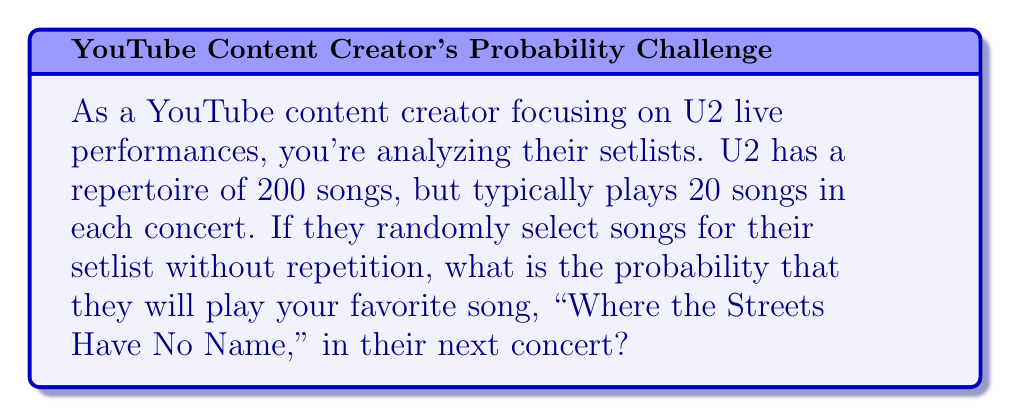Give your solution to this math problem. To solve this problem, we need to use the concept of probability in combination problems. Let's break it down step-by-step:

1) The total number of possible ways to select 20 songs from 200 songs is given by the combination formula:

   $$\binom{200}{20} = \frac{200!}{20!(200-20)!} = \frac{200!}{20!180!}$$

2) Now, we want to calculate the number of ways to select 20 songs that include "Where the Streets Have No Name". This is equivalent to selecting 19 songs from the remaining 199 songs:

   $$\binom{199}{19} = \frac{199!}{19!(199-19)!} = \frac{199!}{19!180!}$$

3) The probability is then the number of favorable outcomes divided by the total number of possible outcomes:

   $$P(\text{Where the Streets Have No Name}) = \frac{\binom{199}{19}}{\binom{200}{20}}$$

4) Simplifying this fraction:

   $$\frac{\frac{199!}{19!180!}}{\frac{200!}{20!180!}} = \frac{199! \cdot 20!180!}{19!180! \cdot 200!} = \frac{199 \cdot 20}{200} = \frac{3980}{200} = 19.9$$

5) Therefore, the probability is:

   $$P(\text{Where the Streets Have No Name}) = \frac{19.9}{200} = 0.0995 = 9.95\%$$
Answer: The probability that U2 will play "Where the Streets Have No Name" in their next concert is $0.0995$ or $9.95\%$. 